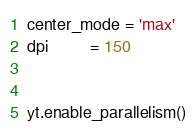<code> <loc_0><loc_0><loc_500><loc_500><_Python_>center_mode = 'max'
dpi         = 150


yt.enable_parallelism()
</code> 